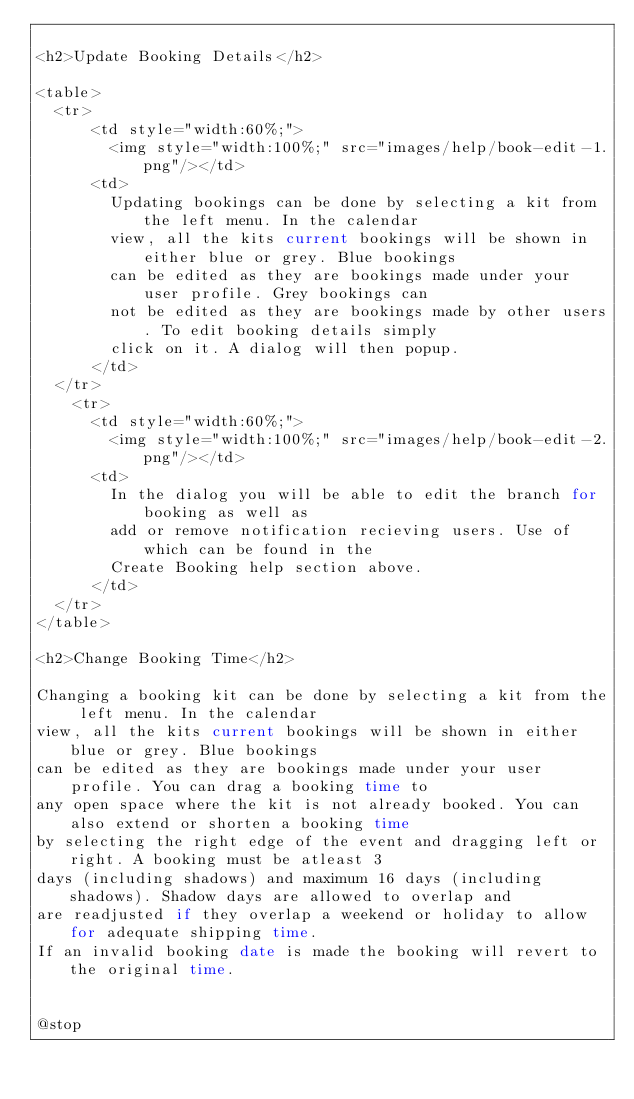Convert code to text. <code><loc_0><loc_0><loc_500><loc_500><_PHP_>
<h2>Update Booking Details</h2>

<table>
	<tr>
	    <td style="width:60%;">
	    	<img style="width:100%;" src="images/help/book-edit-1.png"/></td>
	    <td>
		    Updating bookings can be done by selecting a kit from the left menu. In the calendar 
		    view, all the kits current bookings will be shown in either blue or grey. Blue bookings
		    can be edited as they are bookings made under your user profile. Grey bookings can 
		    not be edited as they are bookings made by other users. To edit booking details simply 
		    click on it. A dialog will then popup.
	    </td>
	</tr>
		<tr>
	    <td style="width:60%;">
	    	<img style="width:100%;" src="images/help/book-edit-2.png"/></td>
	    <td>
	    	In the dialog you will be able to edit the branch for booking as well as
	    	add or remove notification recieving users. Use of which can be found in the 
	    	Create Booking help section above. 
	    </td>
	</tr>
</table>

<h2>Change Booking Time</h2>

Changing a booking kit can be done by selecting a kit from the left menu. In the calendar 
view, all the kits current bookings will be shown in either blue or grey. Blue bookings
can be edited as they are bookings made under your user profile. You can drag a booking time to 
any open space where the kit is not already booked. You can also extend or shorten a booking time
by selecting the right edge of the event and dragging left or right. A booking must be atleast 3 
days (including shadows) and maximum 16 days (including shadows). Shadow days are allowed to overlap and
are readjusted if they overlap a weekend or holiday to allow for adequate shipping time. 
If an invalid booking date is made the booking will revert to the original time.


@stop
</code> 